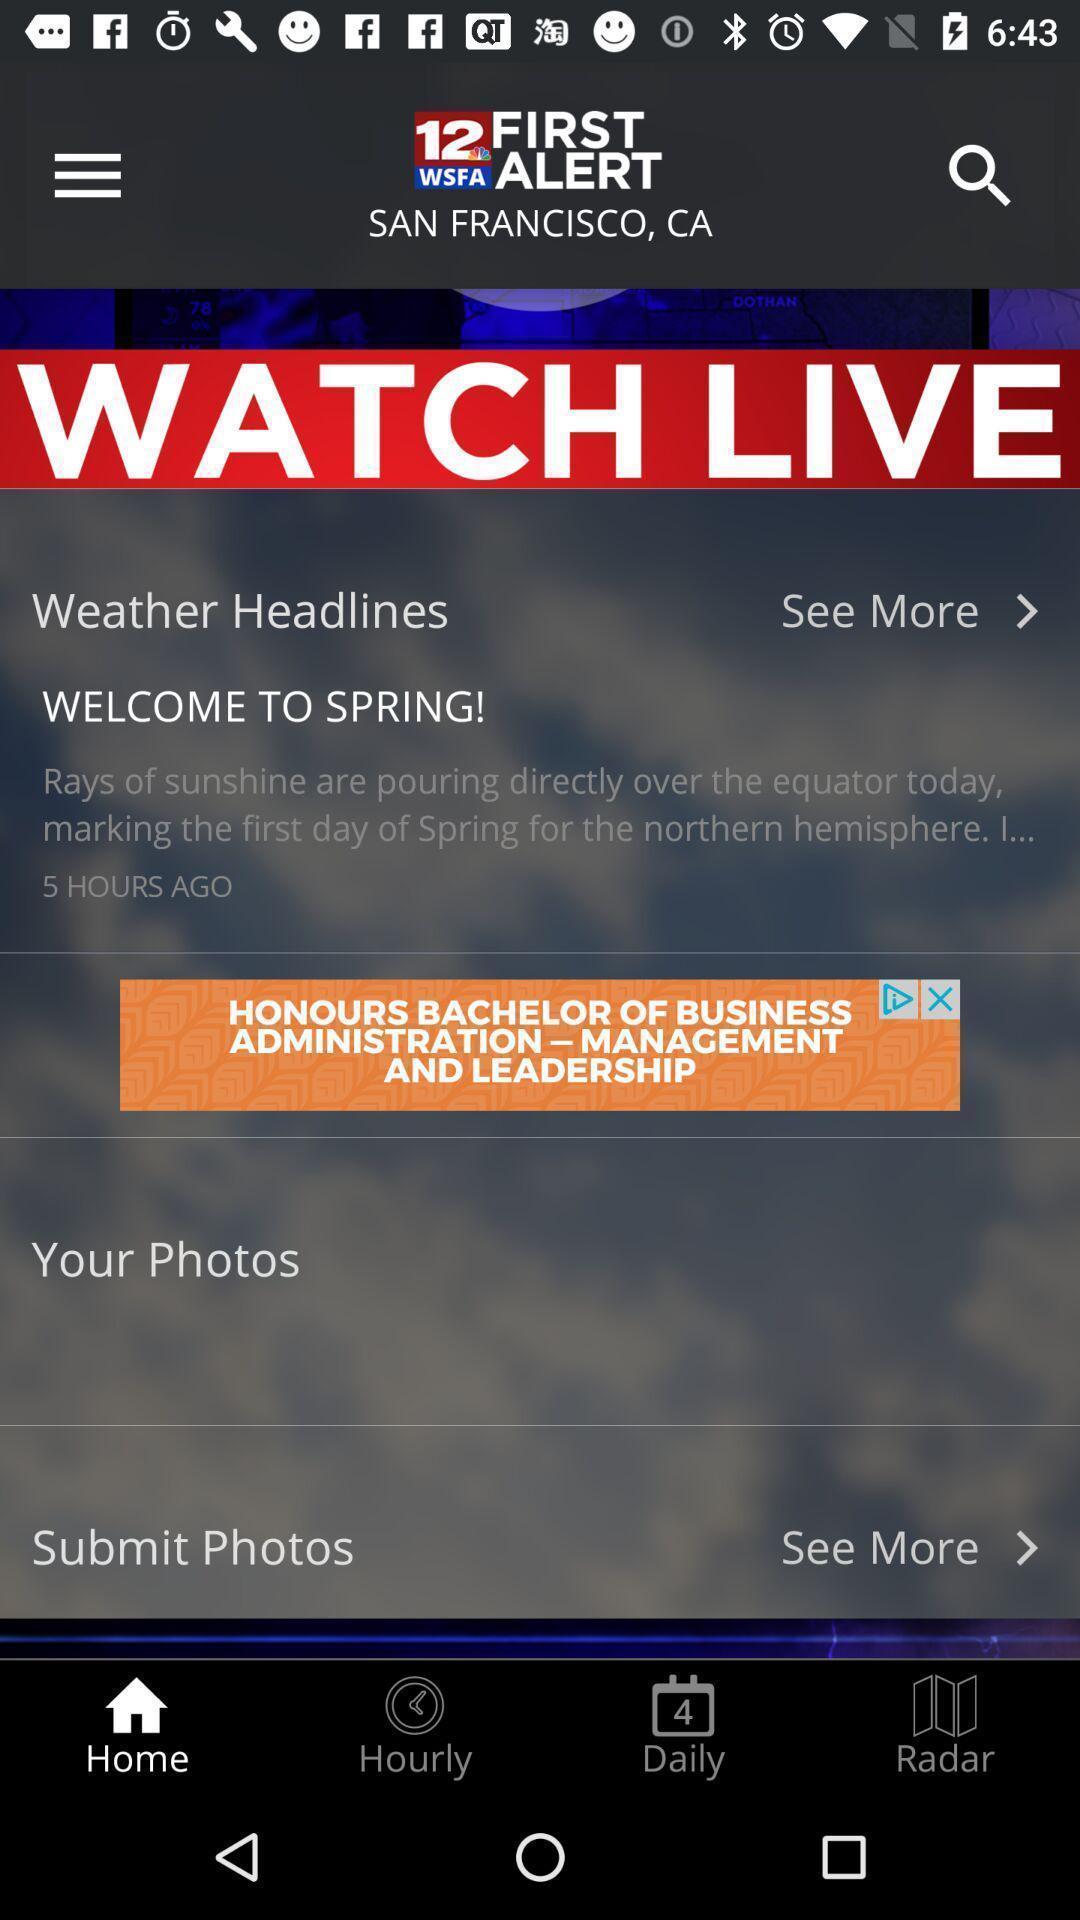Give me a narrative description of this picture. Screen display on live news. 